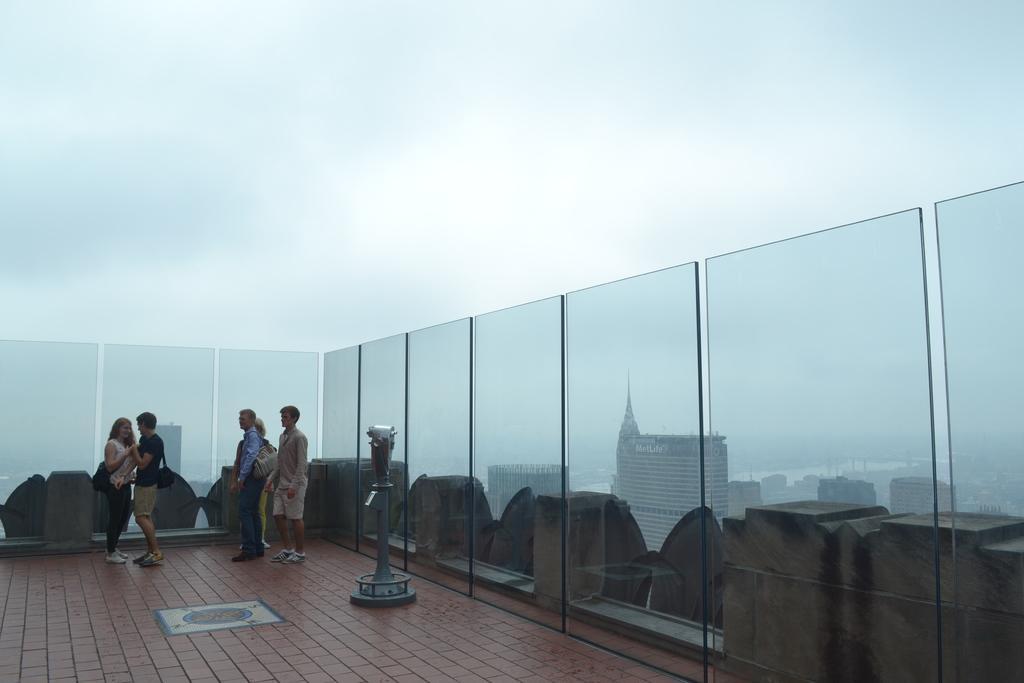How would you summarize this image in a sentence or two? On this roof top we can see people,object and glass walls,through these glass walls we can see buildings. We can see sky. 